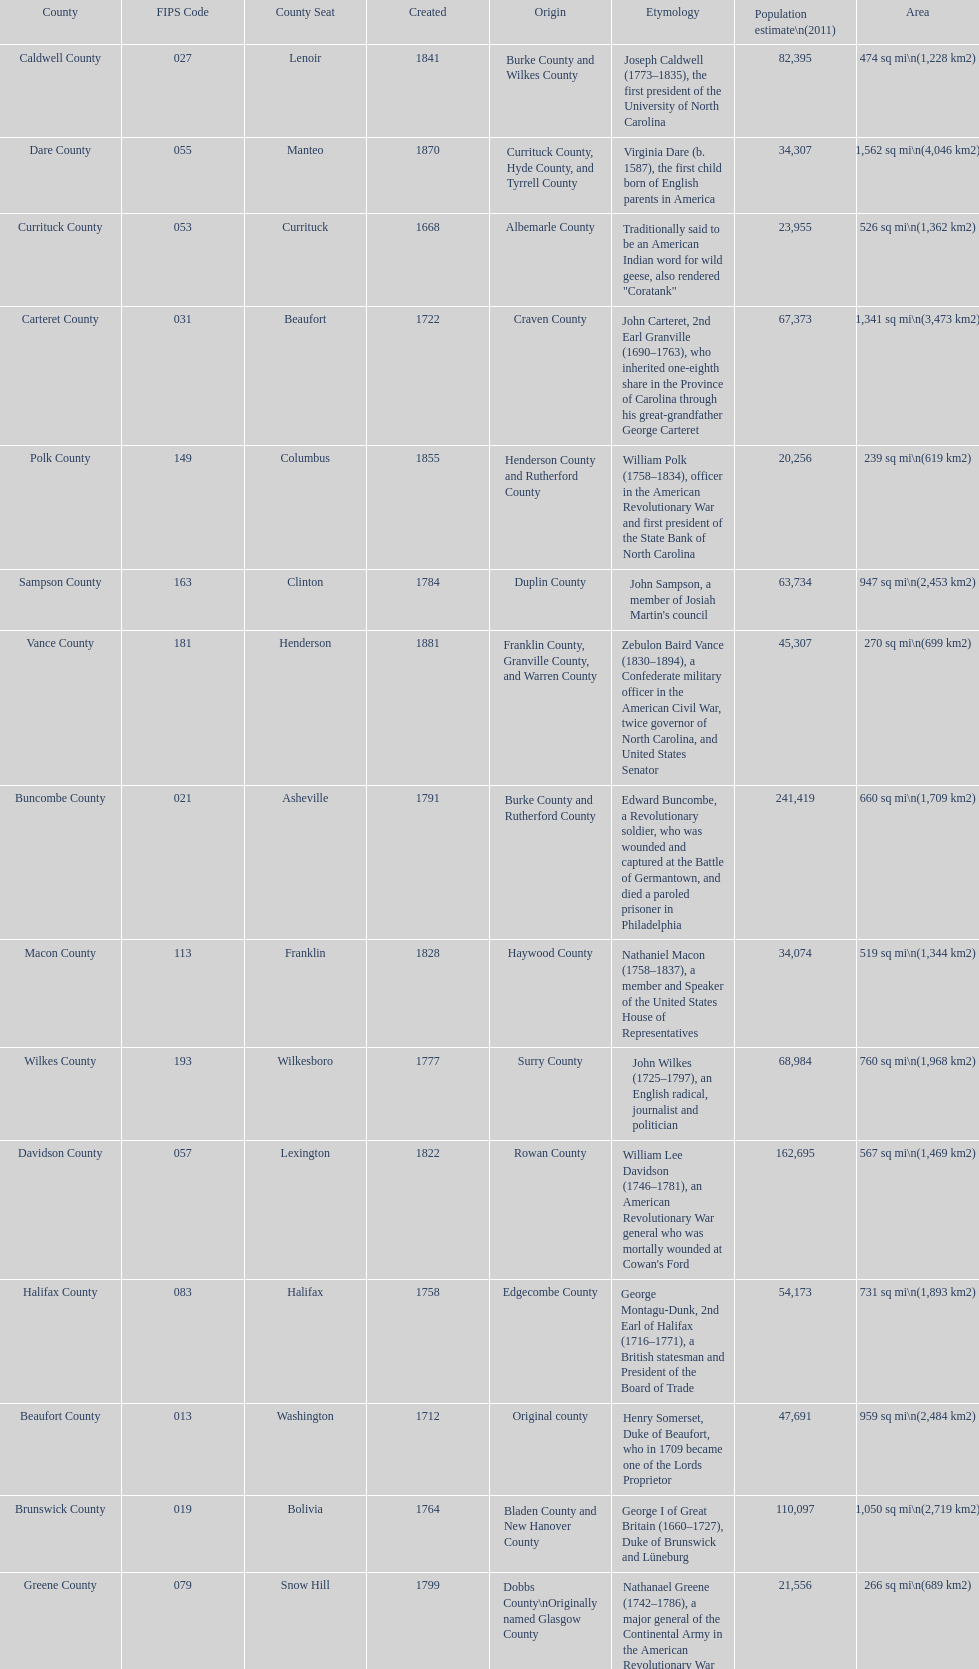What is the total number of counties listed? 100. 